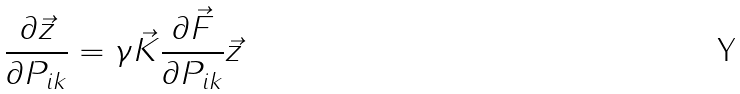<formula> <loc_0><loc_0><loc_500><loc_500>\frac { \partial \vec { z } } { \partial P _ { i k } } = \gamma \vec { K } \frac { \partial \vec { F } } { \partial P _ { i k } } \vec { z }</formula> 